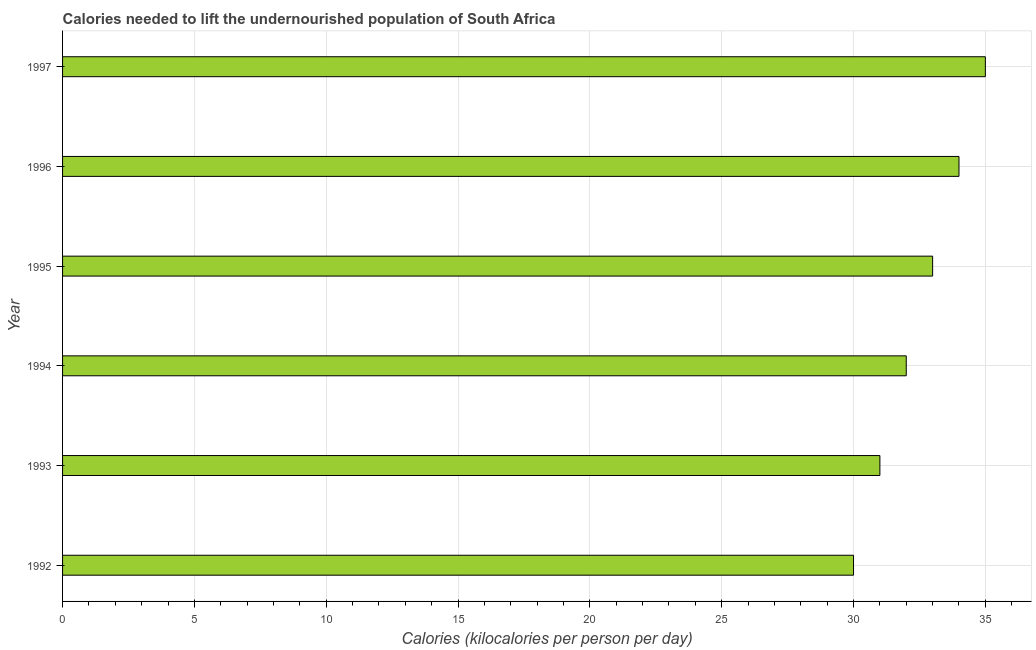Does the graph contain grids?
Your answer should be very brief. Yes. What is the title of the graph?
Give a very brief answer. Calories needed to lift the undernourished population of South Africa. What is the label or title of the X-axis?
Your answer should be compact. Calories (kilocalories per person per day). What is the depth of food deficit in 1995?
Provide a short and direct response. 33. Across all years, what is the maximum depth of food deficit?
Offer a terse response. 35. Across all years, what is the minimum depth of food deficit?
Provide a succinct answer. 30. What is the sum of the depth of food deficit?
Make the answer very short. 195. What is the median depth of food deficit?
Offer a very short reply. 32.5. In how many years, is the depth of food deficit greater than 24 kilocalories?
Make the answer very short. 6. What is the ratio of the depth of food deficit in 1992 to that in 1993?
Your answer should be very brief. 0.97. Is the depth of food deficit in 1993 less than that in 1994?
Offer a very short reply. Yes. Are all the bars in the graph horizontal?
Keep it short and to the point. Yes. Are the values on the major ticks of X-axis written in scientific E-notation?
Ensure brevity in your answer.  No. What is the Calories (kilocalories per person per day) in 1992?
Your answer should be very brief. 30. What is the Calories (kilocalories per person per day) of 1994?
Provide a succinct answer. 32. What is the Calories (kilocalories per person per day) in 1996?
Offer a very short reply. 34. What is the difference between the Calories (kilocalories per person per day) in 1992 and 1993?
Ensure brevity in your answer.  -1. What is the difference between the Calories (kilocalories per person per day) in 1992 and 1994?
Your answer should be very brief. -2. What is the difference between the Calories (kilocalories per person per day) in 1992 and 1995?
Provide a succinct answer. -3. What is the difference between the Calories (kilocalories per person per day) in 1993 and 1995?
Offer a terse response. -2. What is the difference between the Calories (kilocalories per person per day) in 1994 and 1997?
Provide a succinct answer. -3. What is the difference between the Calories (kilocalories per person per day) in 1995 and 1997?
Give a very brief answer. -2. What is the ratio of the Calories (kilocalories per person per day) in 1992 to that in 1994?
Make the answer very short. 0.94. What is the ratio of the Calories (kilocalories per person per day) in 1992 to that in 1995?
Offer a very short reply. 0.91. What is the ratio of the Calories (kilocalories per person per day) in 1992 to that in 1996?
Offer a terse response. 0.88. What is the ratio of the Calories (kilocalories per person per day) in 1992 to that in 1997?
Offer a terse response. 0.86. What is the ratio of the Calories (kilocalories per person per day) in 1993 to that in 1994?
Offer a terse response. 0.97. What is the ratio of the Calories (kilocalories per person per day) in 1993 to that in 1995?
Ensure brevity in your answer.  0.94. What is the ratio of the Calories (kilocalories per person per day) in 1993 to that in 1996?
Make the answer very short. 0.91. What is the ratio of the Calories (kilocalories per person per day) in 1993 to that in 1997?
Your response must be concise. 0.89. What is the ratio of the Calories (kilocalories per person per day) in 1994 to that in 1995?
Ensure brevity in your answer.  0.97. What is the ratio of the Calories (kilocalories per person per day) in 1994 to that in 1996?
Offer a very short reply. 0.94. What is the ratio of the Calories (kilocalories per person per day) in 1994 to that in 1997?
Make the answer very short. 0.91. What is the ratio of the Calories (kilocalories per person per day) in 1995 to that in 1996?
Your response must be concise. 0.97. What is the ratio of the Calories (kilocalories per person per day) in 1995 to that in 1997?
Offer a very short reply. 0.94. 